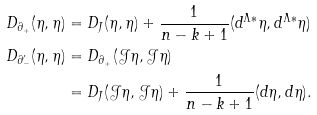<formula> <loc_0><loc_0><loc_500><loc_500>D _ { \partial _ { + } } ( \eta , \eta ) & = D _ { J } ( \eta , \eta ) + \frac { 1 } { n - k + 1 } ( d ^ { \Lambda \ast } \eta , d ^ { \Lambda \ast } \eta ) \\ D _ { \partial _ { - } ^ { \prime } } ( \eta , \eta ) & = D _ { \partial _ { + } } ( \mathcal { J } \eta , \mathcal { J } \eta ) \\ & = D _ { J } ( \mathcal { J } \eta , \mathcal { J } \eta ) + \frac { 1 } { n - k + 1 } ( d \eta , d \eta ) .</formula> 